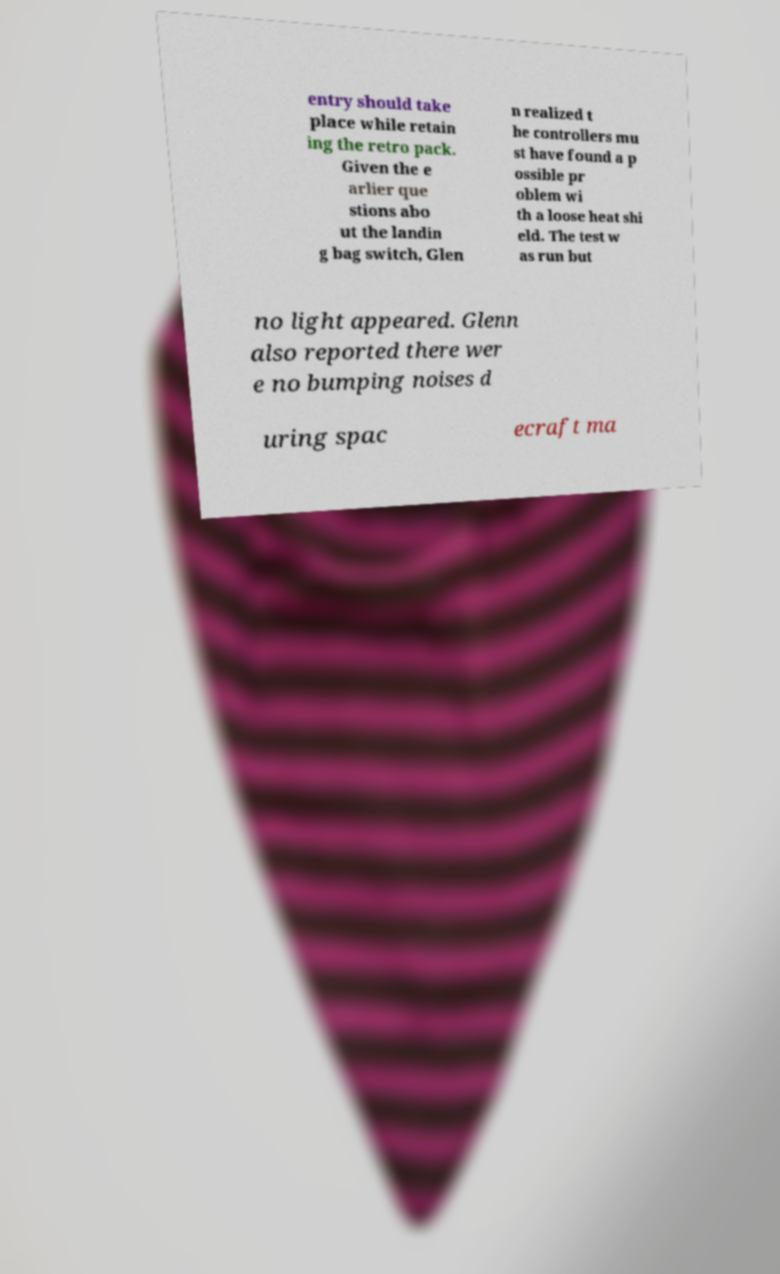I need the written content from this picture converted into text. Can you do that? entry should take place while retain ing the retro pack. Given the e arlier que stions abo ut the landin g bag switch, Glen n realized t he controllers mu st have found a p ossible pr oblem wi th a loose heat shi eld. The test w as run but no light appeared. Glenn also reported there wer e no bumping noises d uring spac ecraft ma 